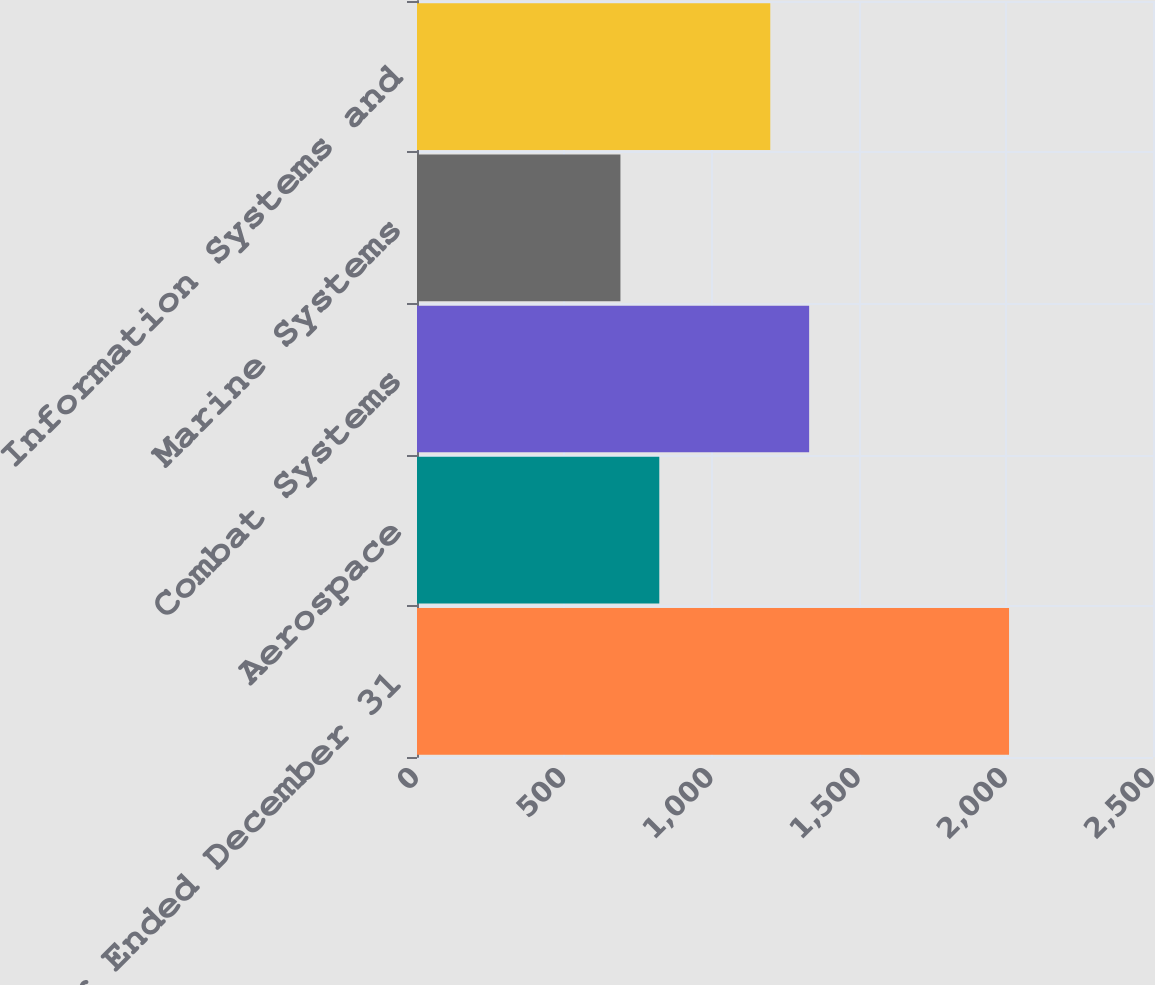<chart> <loc_0><loc_0><loc_500><loc_500><bar_chart><fcel>Year Ended December 31<fcel>Aerospace<fcel>Combat Systems<fcel>Marine Systems<fcel>Information Systems and<nl><fcel>2011<fcel>823<fcel>1332<fcel>691<fcel>1200<nl></chart> 